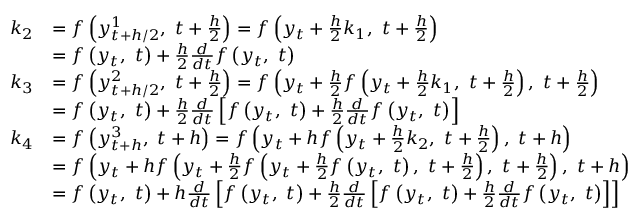<formula> <loc_0><loc_0><loc_500><loc_500>{ \begin{array} { r l } { k _ { 2 } } & { = f \left ( y _ { t + h / 2 } ^ { 1 } , \ t + { \frac { h } { 2 } } \right ) = f \left ( y _ { t } + { \frac { h } { 2 } } k _ { 1 } , \ t + { \frac { h } { 2 } } \right ) } \\ & { = f \left ( y _ { t } , \ t \right ) + { \frac { h } { 2 } } { \frac { d } { d t } } f \left ( y _ { t } , \ t \right ) } \\ { k _ { 3 } } & { = f \left ( y _ { t + h / 2 } ^ { 2 } , \ t + { \frac { h } { 2 } } \right ) = f \left ( y _ { t } + { \frac { h } { 2 } } f \left ( y _ { t } + { \frac { h } { 2 } } k _ { 1 } , \ t + { \frac { h } { 2 } } \right ) , \ t + { \frac { h } { 2 } } \right ) } \\ & { = f \left ( y _ { t } , \ t \right ) + { \frac { h } { 2 } } { \frac { d } { d t } } \left [ f \left ( y _ { t } , \ t \right ) + { \frac { h } { 2 } } { \frac { d } { d t } } f \left ( y _ { t } , \ t \right ) \right ] } \\ { k _ { 4 } } & { = f \left ( y _ { t + h } ^ { 3 } , \ t + h \right ) = f \left ( y _ { t } + h f \left ( y _ { t } + { \frac { h } { 2 } } k _ { 2 } , \ t + { \frac { h } { 2 } } \right ) , \ t + h \right ) } \\ & { = f \left ( y _ { t } + h f \left ( y _ { t } + { \frac { h } { 2 } } f \left ( y _ { t } + { \frac { h } { 2 } } f \left ( y _ { t } , \ t \right ) , \ t + { \frac { h } { 2 } } \right ) , \ t + { \frac { h } { 2 } } \right ) , \ t + h \right ) } \\ & { = f \left ( y _ { t } , \ t \right ) + h { \frac { d } { d t } } \left [ f \left ( y _ { t } , \ t \right ) + { \frac { h } { 2 } } { \frac { d } { d t } } \left [ f \left ( y _ { t } , \ t \right ) + { \frac { h } { 2 } } { \frac { d } { d t } } f \left ( y _ { t } , \ t \right ) \right ] \right ] } \end{array} }</formula> 